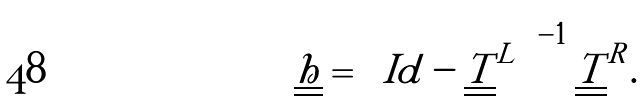Convert formula to latex. <formula><loc_0><loc_0><loc_500><loc_500>\underline { \underline { h } } = \left ( I d - \underline { \underline { T } } ^ { L } \right ) ^ { - 1 } \underline { \underline { T } } ^ { R } .</formula> 